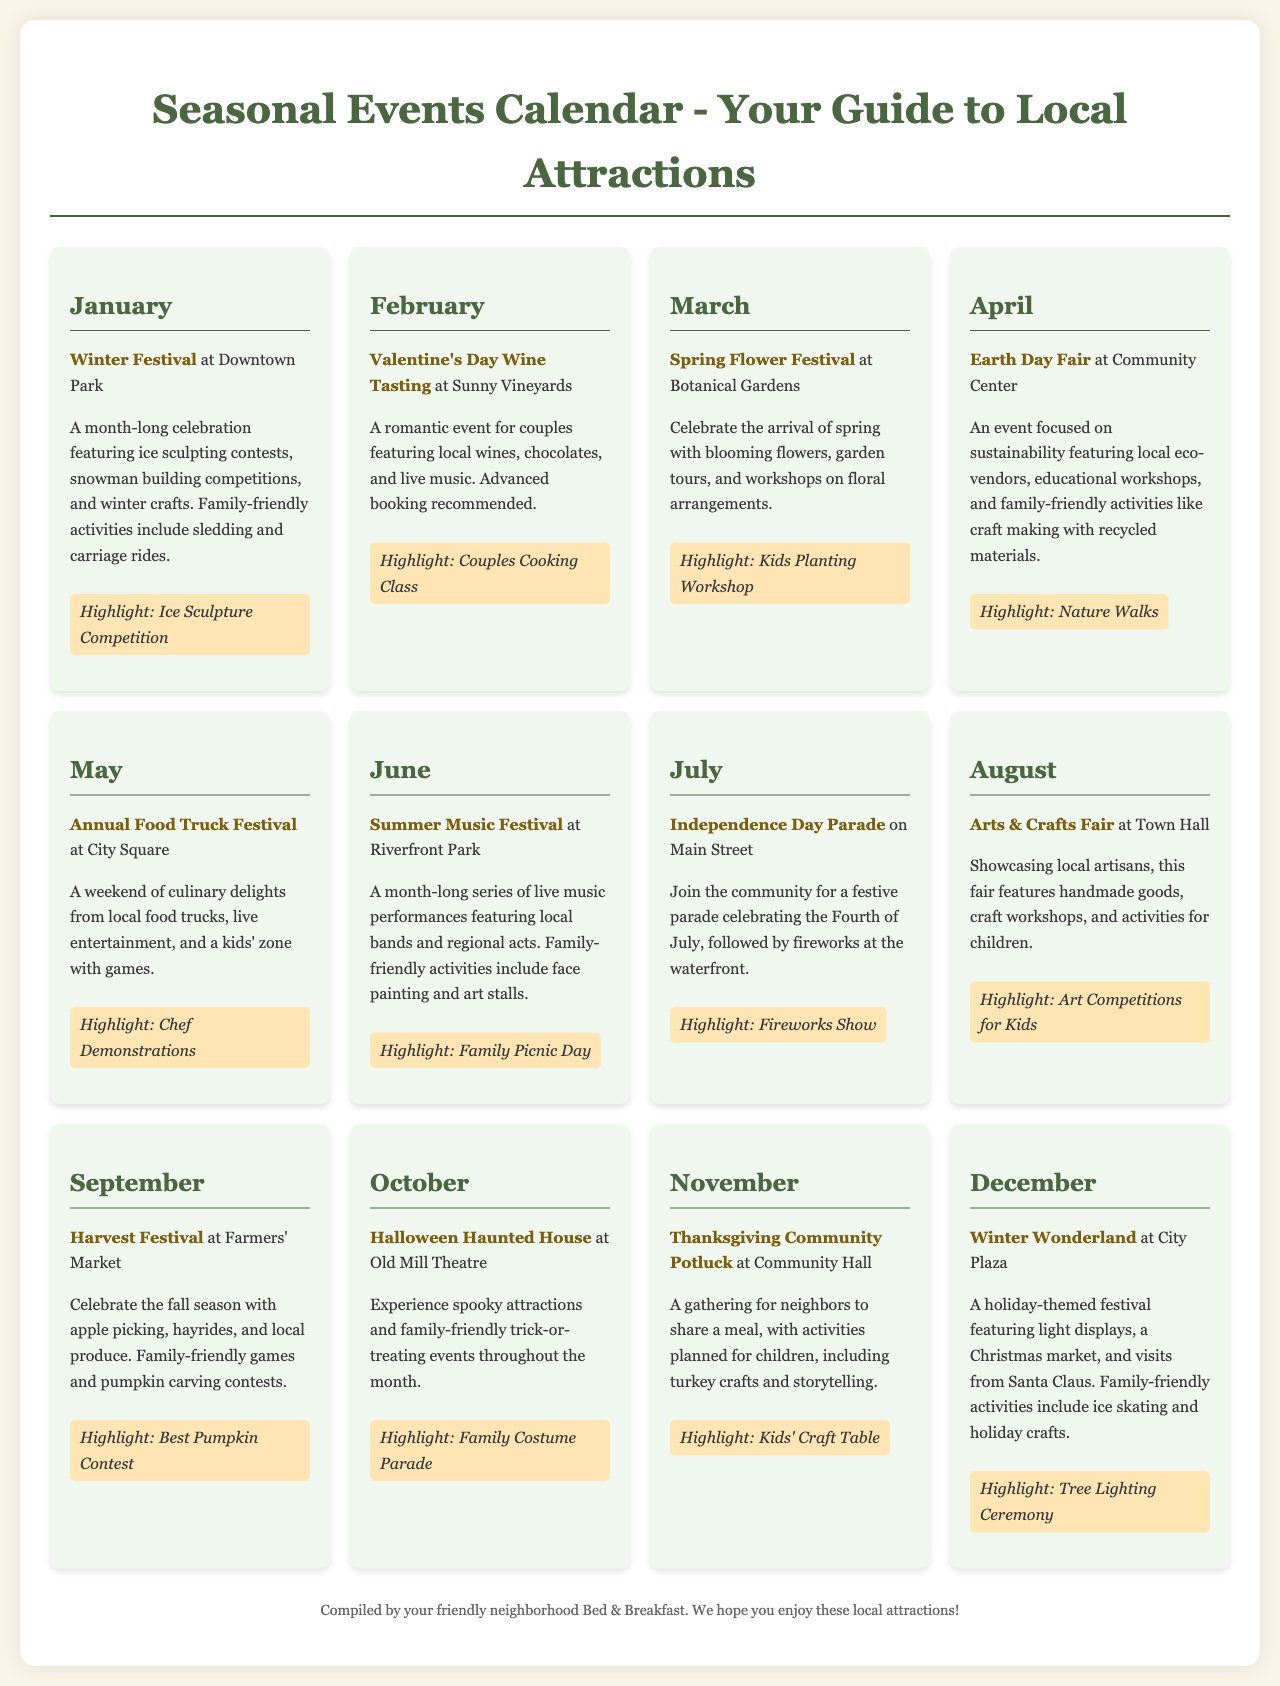what is the first event listed in January? The first event in January is the Winter Festival at Downtown Park.
Answer: Winter Festival what family-friendly activity is highlighted in February? The highlighted family-friendly activity in February is the Couples Cooking Class.
Answer: Couples Cooking Class which month has a focus on sustainability? April features the Earth Day Fair, which focuses on sustainability.
Answer: April how many events are showcased in the month of June? June has one event, the Summer Music Festival at Riverfront Park.
Answer: one what activity is part of the Harvest Festival in September? The Harvest Festival features apple picking and hayrides.
Answer: apple picking which event includes a parade in July? The Independence Day Parade is the event that includes a parade in July.
Answer: Independence Day Parade what is the highlight of the December event? The highlight of the Winter Wonderland in December is the Tree Lighting Ceremony.
Answer: Tree Lighting Ceremony what family-friendly activity occurs during the Halloween event in October? The family-friendly activity during the Halloween Haunted House event is the Family Costume Parade.
Answer: Family Costume Parade which event happens at the Community Center in April? The event that happens at the Community Center in April is the Earth Day Fair.
Answer: Earth Day Fair 